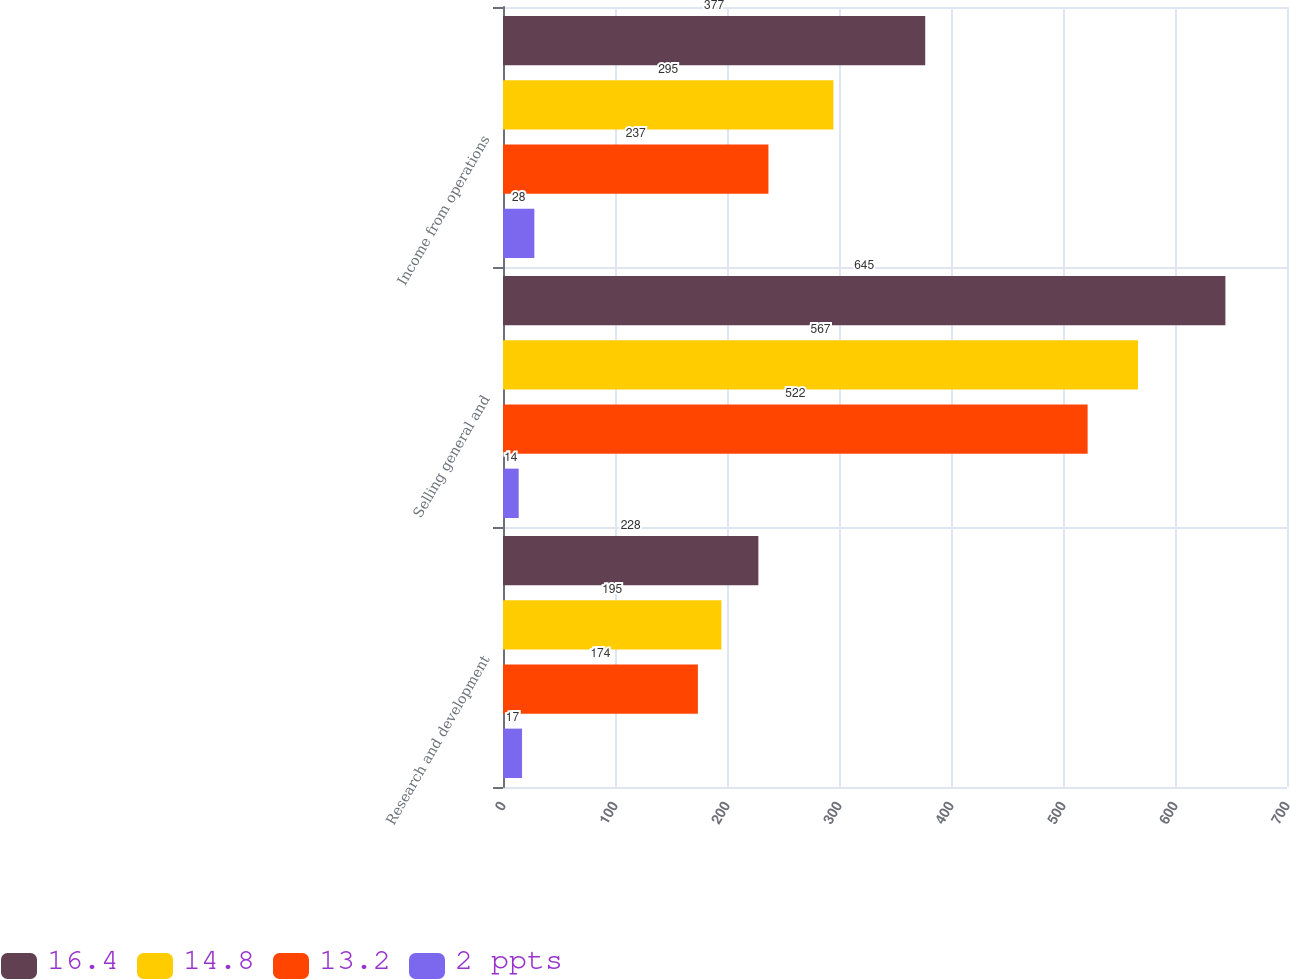<chart> <loc_0><loc_0><loc_500><loc_500><stacked_bar_chart><ecel><fcel>Research and development<fcel>Selling general and<fcel>Income from operations<nl><fcel>16.4<fcel>228<fcel>645<fcel>377<nl><fcel>14.8<fcel>195<fcel>567<fcel>295<nl><fcel>13.2<fcel>174<fcel>522<fcel>237<nl><fcel>2 ppts<fcel>17<fcel>14<fcel>28<nl></chart> 